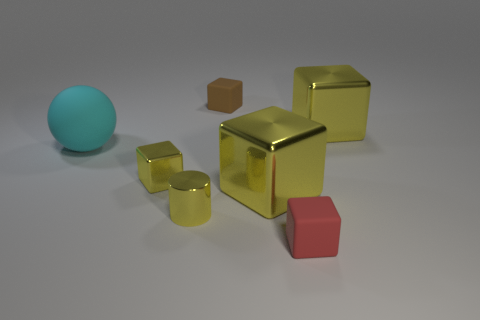What can you infer about the size of these objects? Based on their relative proportions and assuming a consistent scale, the objects vary in size. The blue sphere is the largest, the golden cube is medium-sized, and the smaller shapes like the tiny cubes and cylinder appear to be miniature models. 